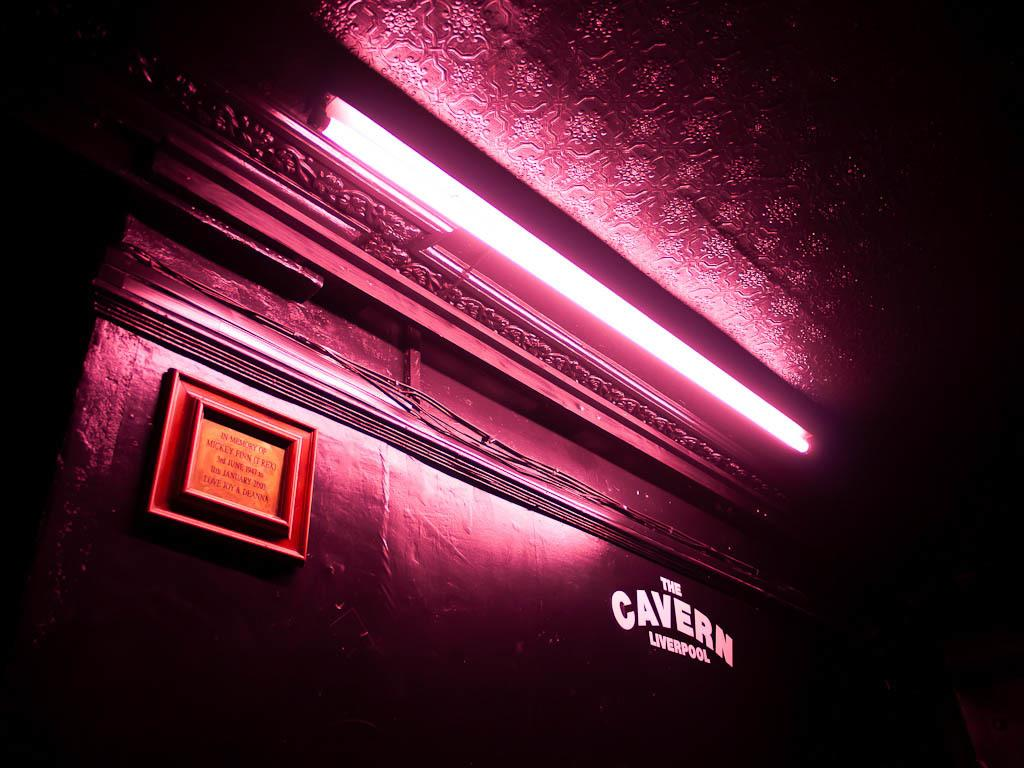What type of structure is visible in the image? There is a building in the image. What color is the wall in front of the building? The wall in front of the building is pink. Can you describe any light source in the image? Yes, there is a light visible in the image. What object can be seen near the building? There is a board in the image. What is written on the board? There is text on the board. What type of soda is being advertised on the pink wall in the image? There is no soda being advertised on the pink wall in the image; it is a plain pink wall. Can you see a boot on the roof of the building in the image? There is no boot visible on the roof of the building in the image. 